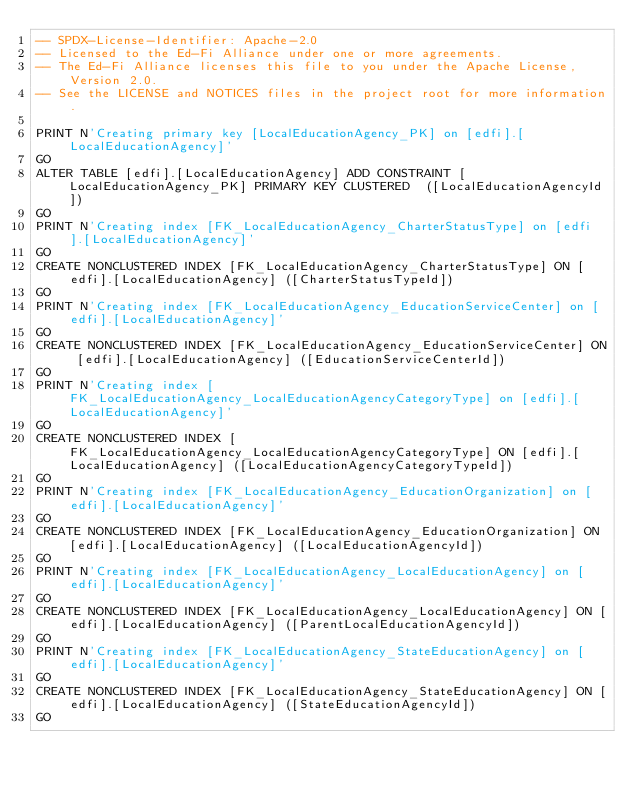<code> <loc_0><loc_0><loc_500><loc_500><_SQL_>-- SPDX-License-Identifier: Apache-2.0
-- Licensed to the Ed-Fi Alliance under one or more agreements.
-- The Ed-Fi Alliance licenses this file to you under the Apache License, Version 2.0.
-- See the LICENSE and NOTICES files in the project root for more information.

PRINT N'Creating primary key [LocalEducationAgency_PK] on [edfi].[LocalEducationAgency]'
GO
ALTER TABLE [edfi].[LocalEducationAgency] ADD CONSTRAINT [LocalEducationAgency_PK] PRIMARY KEY CLUSTERED  ([LocalEducationAgencyId])
GO
PRINT N'Creating index [FK_LocalEducationAgency_CharterStatusType] on [edfi].[LocalEducationAgency]'
GO
CREATE NONCLUSTERED INDEX [FK_LocalEducationAgency_CharterStatusType] ON [edfi].[LocalEducationAgency] ([CharterStatusTypeId])
GO
PRINT N'Creating index [FK_LocalEducationAgency_EducationServiceCenter] on [edfi].[LocalEducationAgency]'
GO
CREATE NONCLUSTERED INDEX [FK_LocalEducationAgency_EducationServiceCenter] ON [edfi].[LocalEducationAgency] ([EducationServiceCenterId])
GO
PRINT N'Creating index [FK_LocalEducationAgency_LocalEducationAgencyCategoryType] on [edfi].[LocalEducationAgency]'
GO
CREATE NONCLUSTERED INDEX [FK_LocalEducationAgency_LocalEducationAgencyCategoryType] ON [edfi].[LocalEducationAgency] ([LocalEducationAgencyCategoryTypeId])
GO
PRINT N'Creating index [FK_LocalEducationAgency_EducationOrganization] on [edfi].[LocalEducationAgency]'
GO
CREATE NONCLUSTERED INDEX [FK_LocalEducationAgency_EducationOrganization] ON [edfi].[LocalEducationAgency] ([LocalEducationAgencyId])
GO
PRINT N'Creating index [FK_LocalEducationAgency_LocalEducationAgency] on [edfi].[LocalEducationAgency]'
GO
CREATE NONCLUSTERED INDEX [FK_LocalEducationAgency_LocalEducationAgency] ON [edfi].[LocalEducationAgency] ([ParentLocalEducationAgencyId])
GO
PRINT N'Creating index [FK_LocalEducationAgency_StateEducationAgency] on [edfi].[LocalEducationAgency]'
GO
CREATE NONCLUSTERED INDEX [FK_LocalEducationAgency_StateEducationAgency] ON [edfi].[LocalEducationAgency] ([StateEducationAgencyId])
GO

</code> 